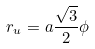<formula> <loc_0><loc_0><loc_500><loc_500>r _ { u } = a \frac { \sqrt { 3 } } { 2 } \phi</formula> 